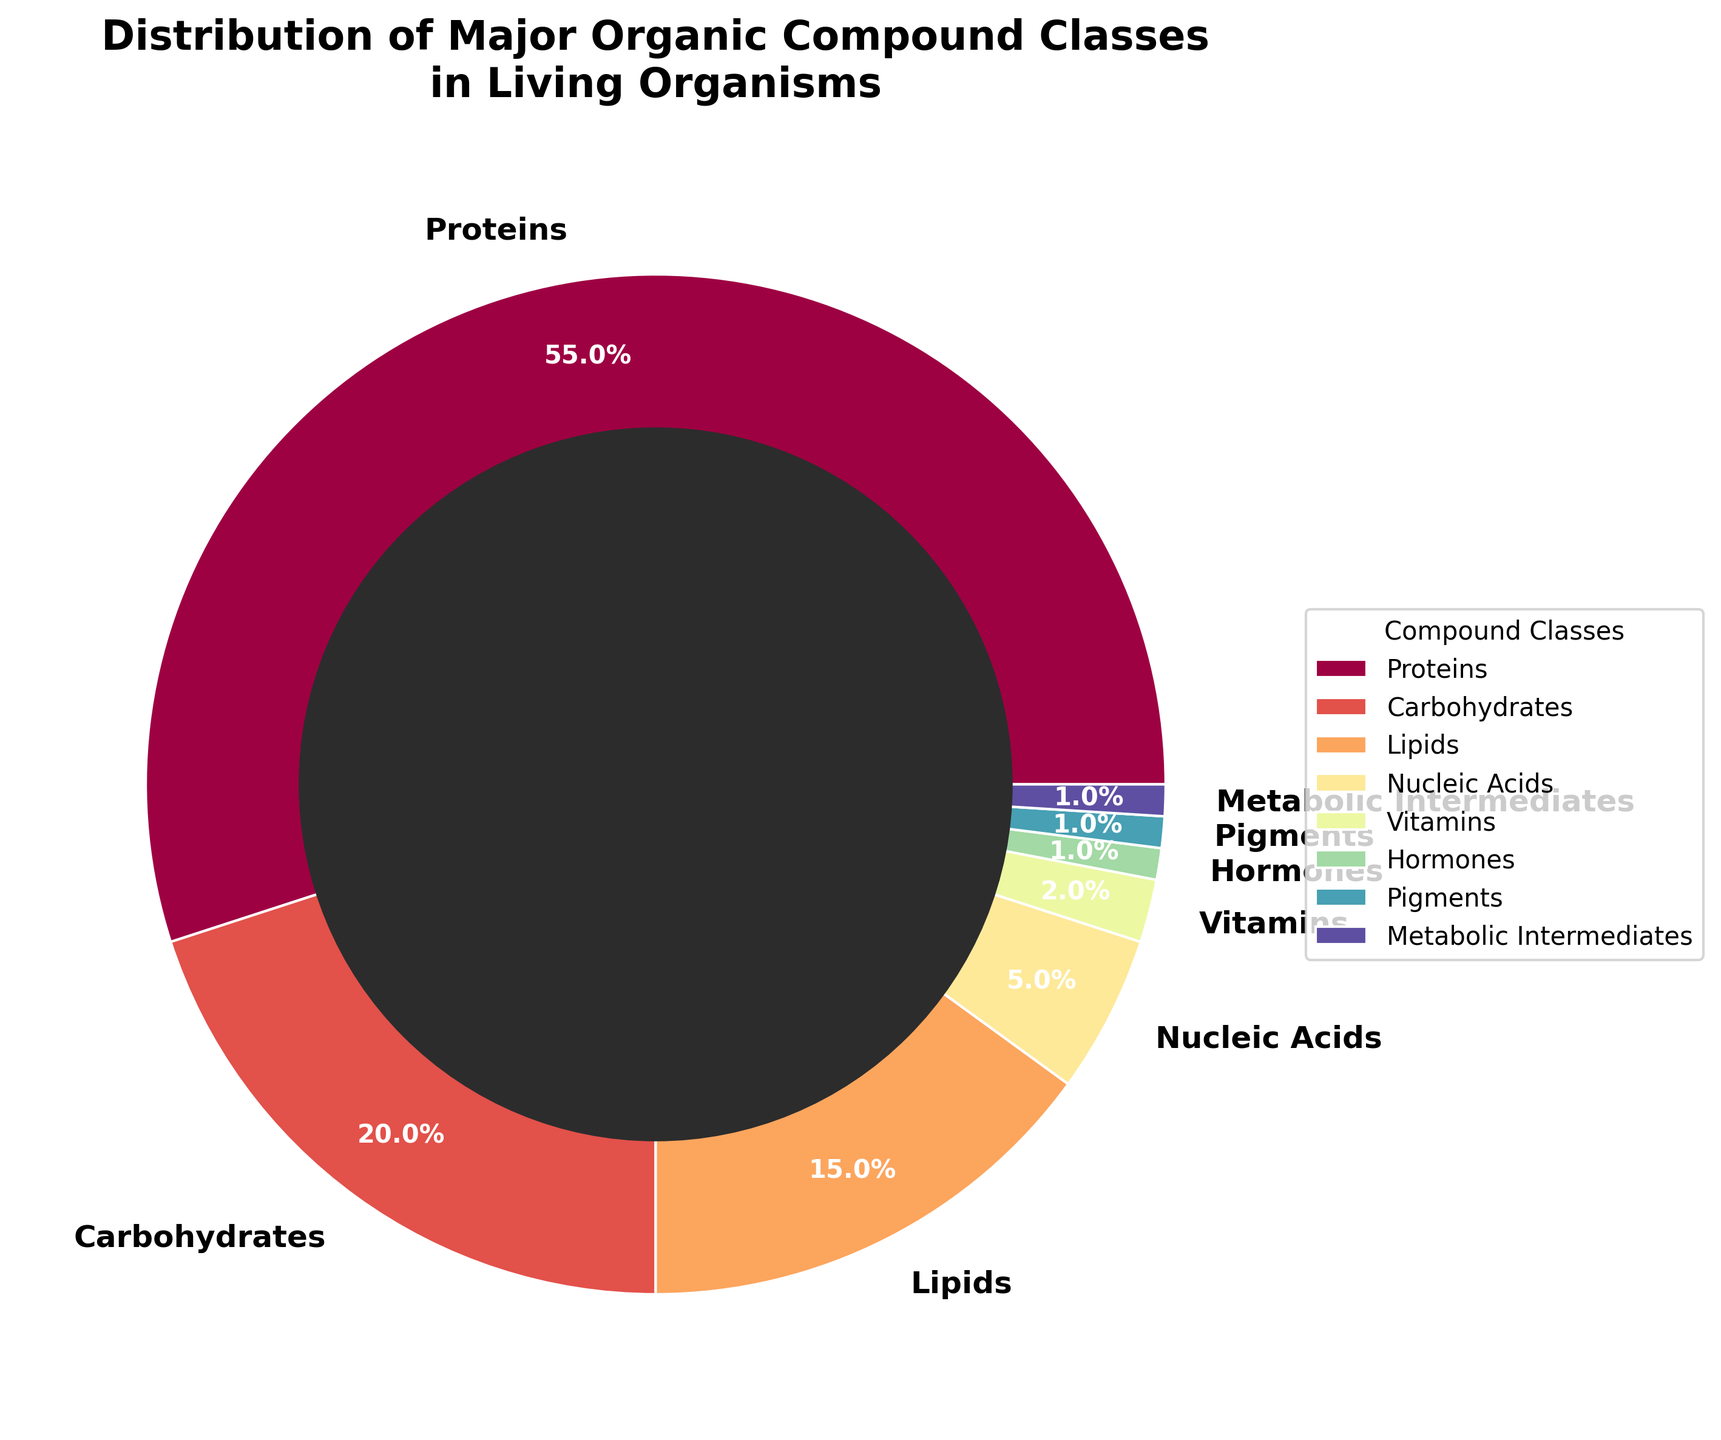How many compound classes are present in the pie chart? Count the number of unique labels in the chart: Proteins, Carbohydrates, Lipids, Nucleic Acids, Vitamins, Hormones, Pigments, Metabolic Intermediates.
Answer: 8 Which compound class has the highest percentage? Identify the segment with the largest percentage label. Proteins are labeled with the highest percentage of 55%.
Answer: Proteins What is the combined percentage of Lipids and Nucleic Acids? Find the individual percentages for Lipids (15%) and Nucleic Acids (5%) and add them together. 15% + 5% = 20%.
Answer: 20% Are Hormones and Pigments equal in their percentage distribution? Check the percentage labels for Hormones and Pigments. Both are labeled as 1%.
Answer: Yes How much larger is the percentage of Carbohydrates compared to Vitamins? Subtract the percentage of Vitamins (2%) from Carbohydrates (20%). 20% - 2% = 18%.
Answer: 18% If Proteins and Carbohydrates together form more than half of the total, what percentage do they represent? Add the percentages of Proteins (55%) and Carbohydrates (20%). 55% + 20% = 75%.
Answer: 75% Which segment is visually the smallest in the pie chart? Identify the segments with the smallest percentage labels (Hormones, Pigments, and Metabolic Intermediates are all 1%). Since they are equal, any of the three is correct.
Answer: Hormones/Pigments/Metabolic Intermediates What is the total percentage of compounds other than Proteins and Carbohydrates? Subtract the combined percentage of Proteins (55%) and Carbohydrates (20%) from 100%. 100% - 55% - 20% = 25%.
Answer: 25% Which compound class, Lipids or Nucleic Acids, occupies a larger segment in the pie chart? Compare the percentage labels of Lipids (15%) and Nucleic Acids (5%). Lipids have a larger percentage.
Answer: Lipids If you combine the percentages of Vitamins, Hormones, Pigments, and Metabolic Intermediates, what is the total? Add the percentages: Vitamins (2%), Hormones (1%), Pigments (1%), Metabolic Intermediates (1%). 2% + 1% + 1% + 1% = 5%.
Answer: 5% 